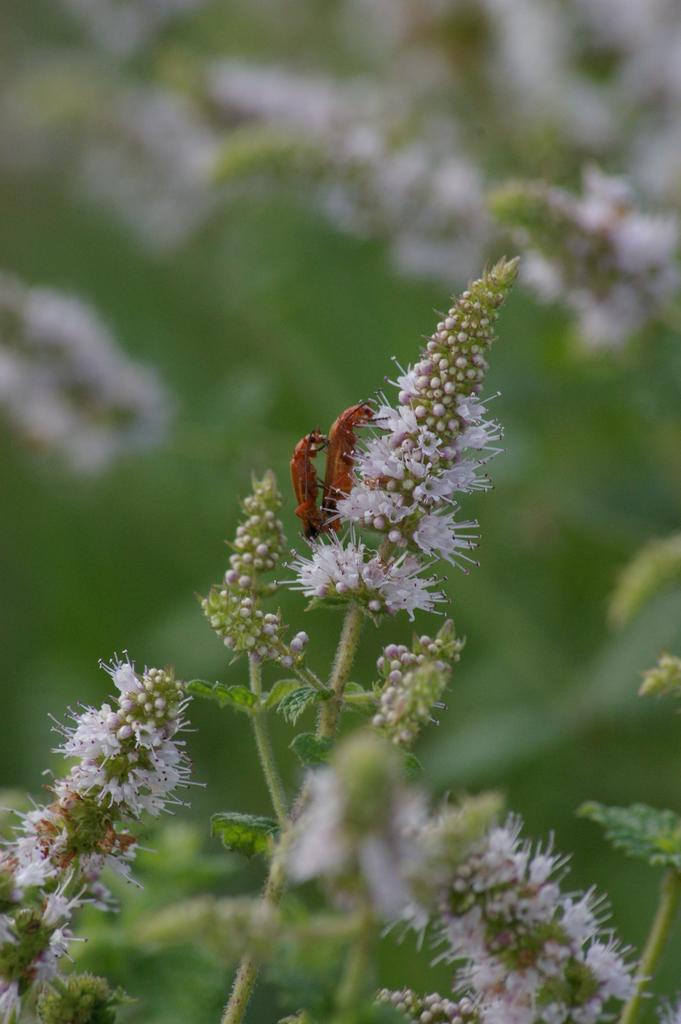Please provide a concise description of this image. In this picture we can see insects and flowers in the front, we can see a blurry background. 